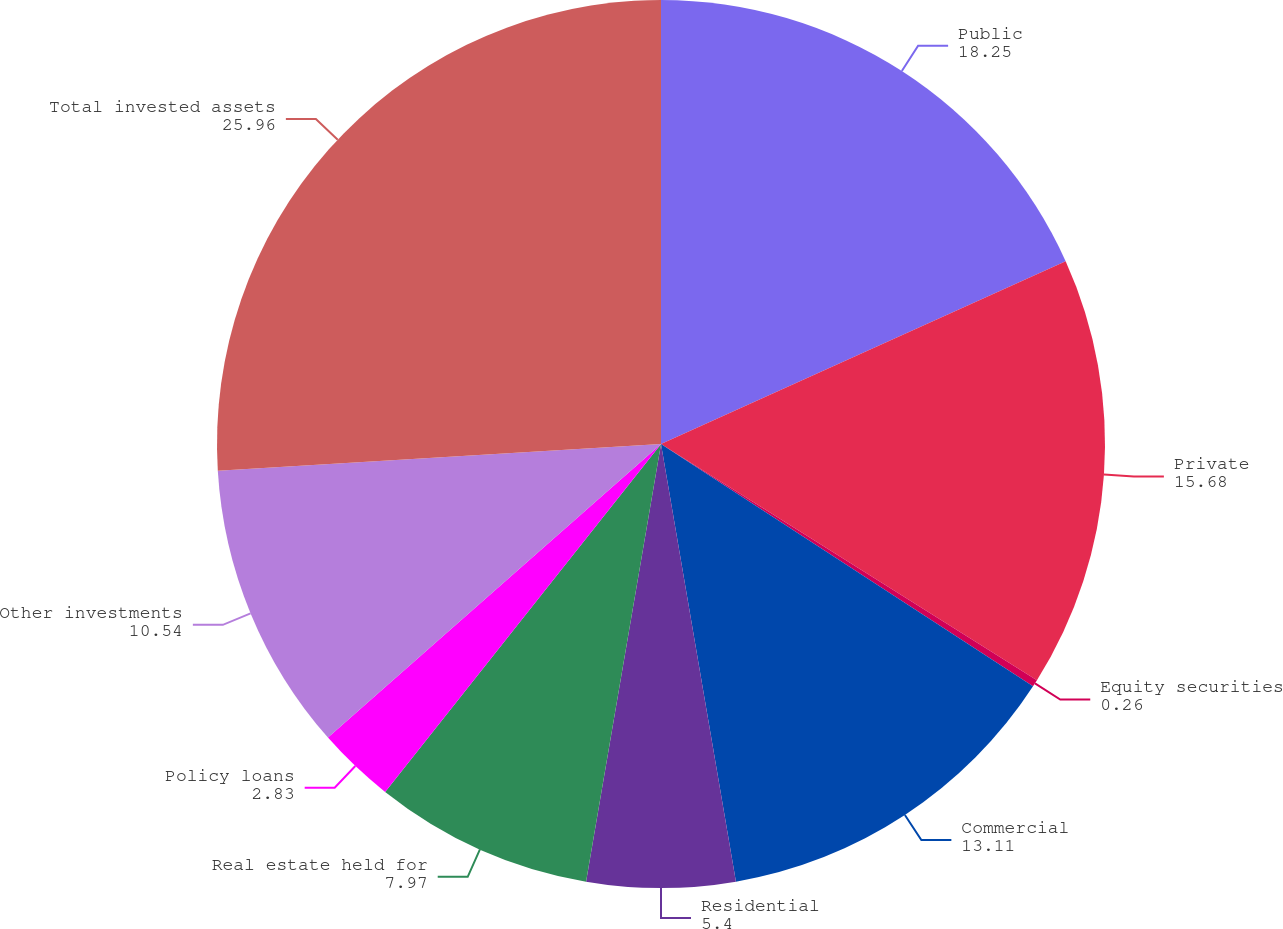<chart> <loc_0><loc_0><loc_500><loc_500><pie_chart><fcel>Public<fcel>Private<fcel>Equity securities<fcel>Commercial<fcel>Residential<fcel>Real estate held for<fcel>Policy loans<fcel>Other investments<fcel>Total invested assets<nl><fcel>18.25%<fcel>15.68%<fcel>0.26%<fcel>13.11%<fcel>5.4%<fcel>7.97%<fcel>2.83%<fcel>10.54%<fcel>25.96%<nl></chart> 